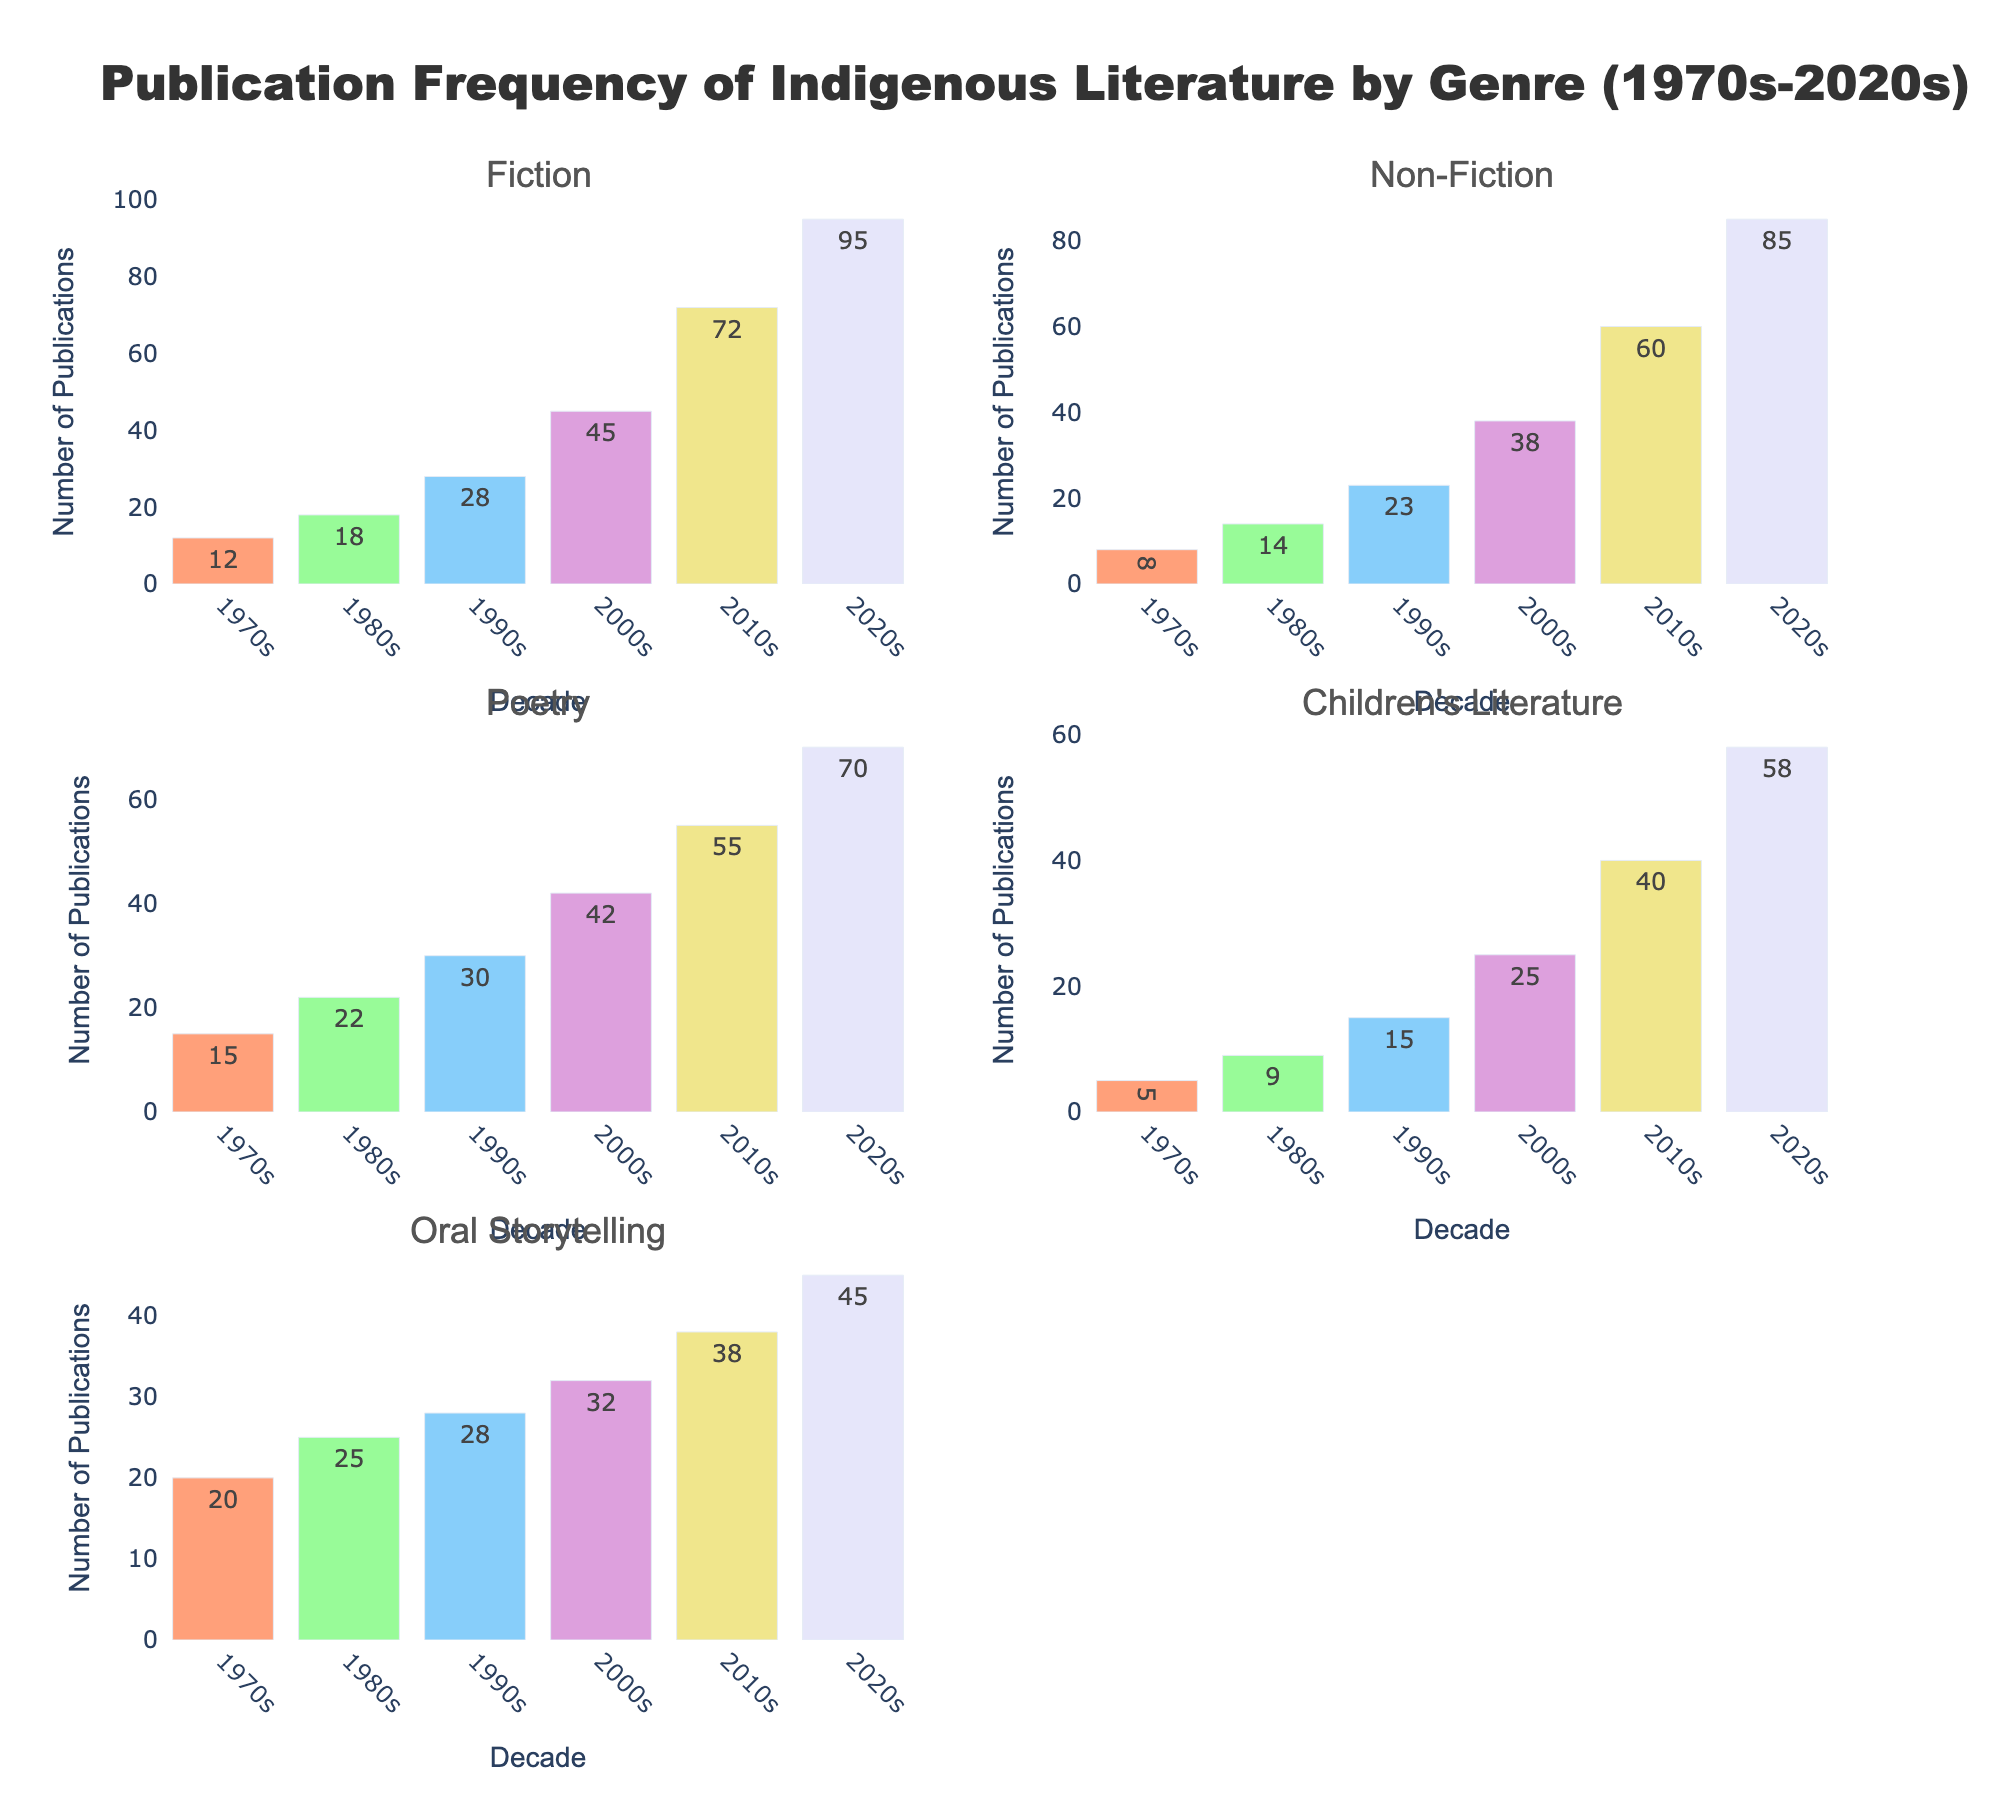What is the title of the figure? The title is written above the subplots and indicates the main topic of the figure. It states, "Publication Frequency of Indigenous Literature by Genre (1970s-2020s)"
Answer: Publication Frequency of Indigenous Literature by Genre (1970s-2020s) How many genres are represented in the figure? There are six subplot titles, each representing a different genre. These are Fiction, Non-Fiction, Poetry, Children's Literature, and Oral Storytelling.
Answer: 5 Which decade had the highest number of Fiction publications? Look at the Fiction subplot and compare the number of publications across all decades. The 2020s bar is the highest.
Answer: 2020s What is the total number of Poetry publications in the 2010s? Locate the Poetry subplot and find the bar for the decade labeled "2010s." The number displayed above the bar is the total number of publications.
Answer: 55 How does the growth in Non-Fiction publications from the 1970s to the 2020s compare to that in Oral Storytelling? For Non-Fiction, subtract the 1970s value (8) from the 2020s value (85) to get the growth. For Oral Storytelling, subtract the 1970s value (20) from the 2020s value (45) to get the growth. Compare these two results.
Answer: 77 (Non-Fiction), 25 (Oral Storytelling) Which genre had the most publications in the 2000s? Compare the heights of the bars for the 2000s across all subplots. The highest bar in the 2000s is for Oral Storytelling with 32 publications.
Answer: Oral Storytelling What is the percentage increase in Fiction publications from the 1980s to the 2010s? Find the Fiction publications in the 1980s (18) and the 2010s (72). Calculate the difference (72 - 18 = 54), then divide by the 1980s value and multiply by 100 for the percentage increase. (54 / 18) * 100 = 300%.
Answer: 300% In which decade did Childrens' Literature see the largest increase in publications from the previous decade? Compare the numeric differences for each decade transition: 1970s to 1980s (9 - 5), 1980s to 1990s (15 - 9), 1990s to 2000s (25 - 15), 2000s to 2010s (40 - 25), and 2010s to 2020s (58 - 40). The largest difference is from 2010s to 2020s, which is 18 (58-40).
Answer: 2010s to 2020s How do the total publications in the 2020s across all genres compare with those in the 1990s? Sum the values for all genres in the 2020s (95 + 85 + 70 + 58 + 45 = 353) and in the 1990s (28 + 23 + 30 + 15 + 28 = 124). Compare the two totals.
Answer: 353 (2020s), 124 (1990s) Which genre experienced the smallest increase in publications from the 2000s to the 2010s? Calculate the numeric difference for each genre between the 2000s and 2010s: Fiction (72-45=27), Non-Fiction (60-38=22), Poetry (55-42=13), Children's Literature (40-25=15), Oral Storytelling (38-32=6). The smallest increase is in Oral Storytelling.
Answer: Oral Storytelling 